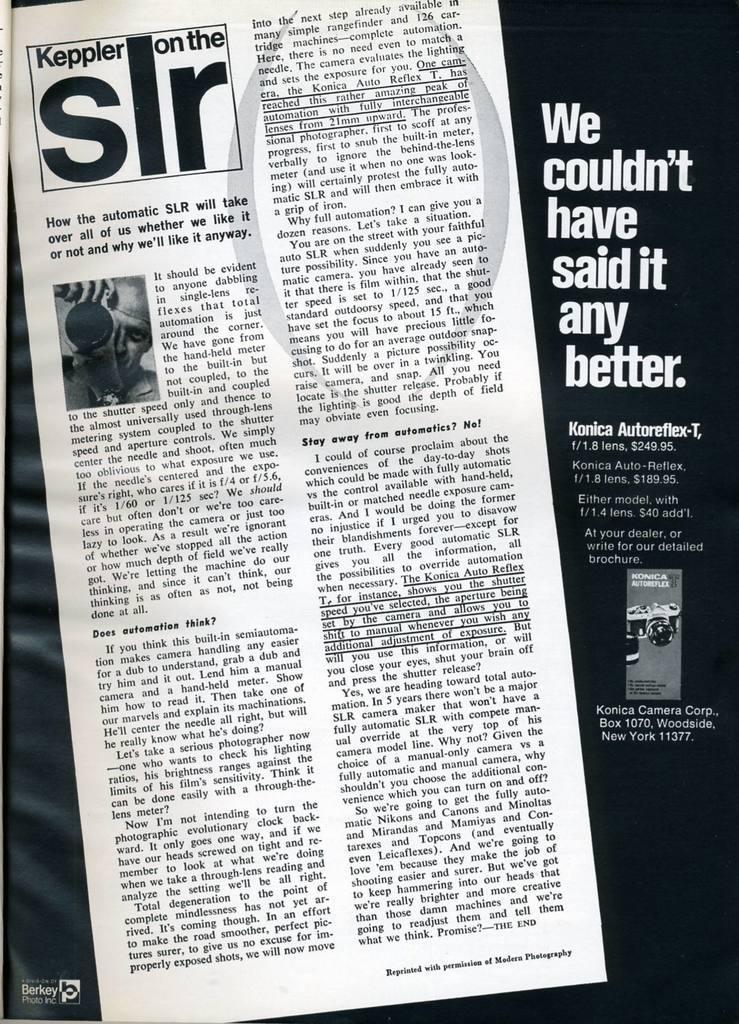Describe this image in one or two sentences. In this image in the center there is one newspaper, on the paper there is some text and on the right side also there is some text and some object. 